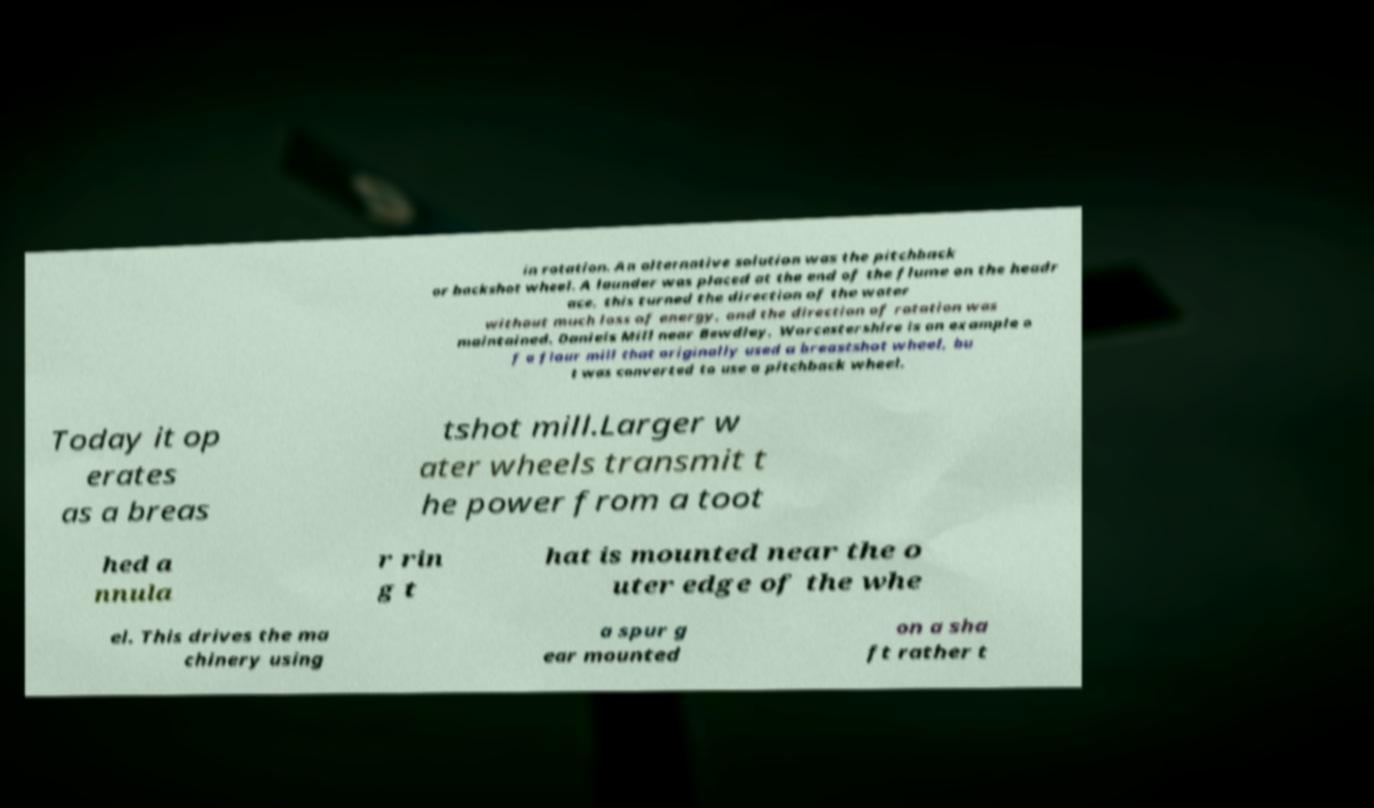For documentation purposes, I need the text within this image transcribed. Could you provide that? in rotation. An alternative solution was the pitchback or backshot wheel. A launder was placed at the end of the flume on the headr ace, this turned the direction of the water without much loss of energy, and the direction of rotation was maintained. Daniels Mill near Bewdley, Worcestershire is an example o f a flour mill that originally used a breastshot wheel, bu t was converted to use a pitchback wheel. Today it op erates as a breas tshot mill.Larger w ater wheels transmit t he power from a toot hed a nnula r rin g t hat is mounted near the o uter edge of the whe el. This drives the ma chinery using a spur g ear mounted on a sha ft rather t 